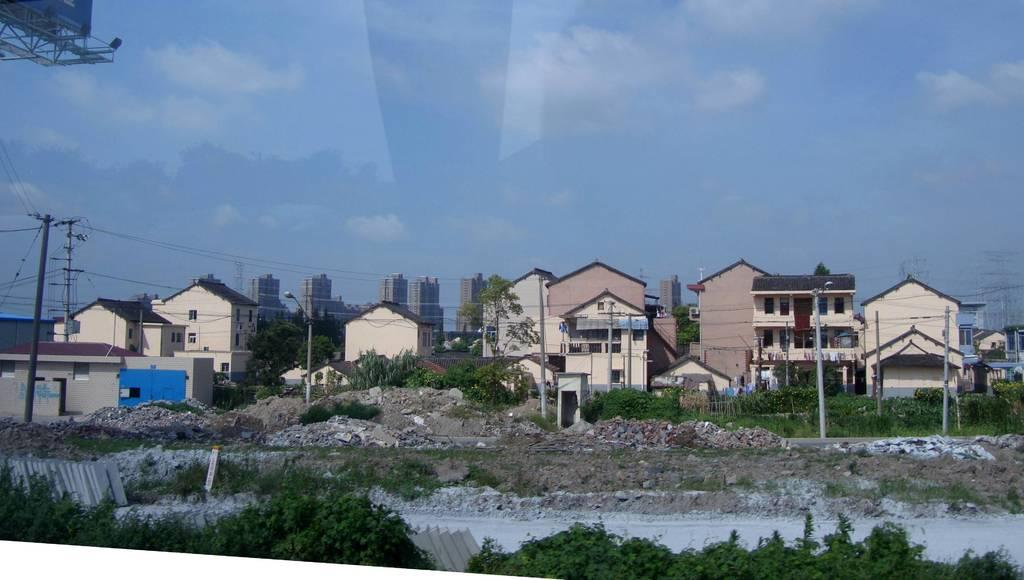What type of living organisms can be seen in the image? Plants can be seen in the image. What structures are present in the image? There are poles with wires and lights on the poles. What type of buildings can be seen in the image? There are houses and buildings in the image. What can be seen in the background of the image? Trees, buildings, and the sky are visible in the background of the image. What type of silk is being used to make the governor's robe in the image? There is no governor or silk present in the image. What is the need for the lights on the poles in the image? The purpose of the lights on the poles is not specified in the image, but they could be for illumination or signaling. 